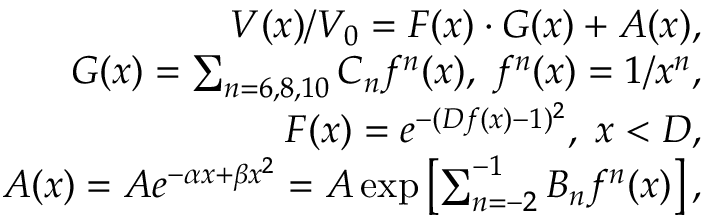<formula> <loc_0><loc_0><loc_500><loc_500>\begin{array} { r l r } & { V ( x ) / V _ { 0 } = F ( x ) \cdot G ( x ) + A ( x ) , } \\ & { G ( x ) = \sum _ { n = 6 , 8 , 1 0 } C _ { n } f ^ { n } ( x ) , \, f ^ { n } ( x ) = 1 / x ^ { n } , } \\ & { F ( x ) = e ^ { - ( D f ( x ) - 1 ) ^ { 2 } } , \, x < D , } \\ & { A ( x ) = A e ^ { - \alpha x + \beta x ^ { 2 } } = A \exp \left [ \sum _ { n = - 2 } ^ { - 1 } B _ { n } f ^ { n } ( x ) \right ] , } \end{array}</formula> 